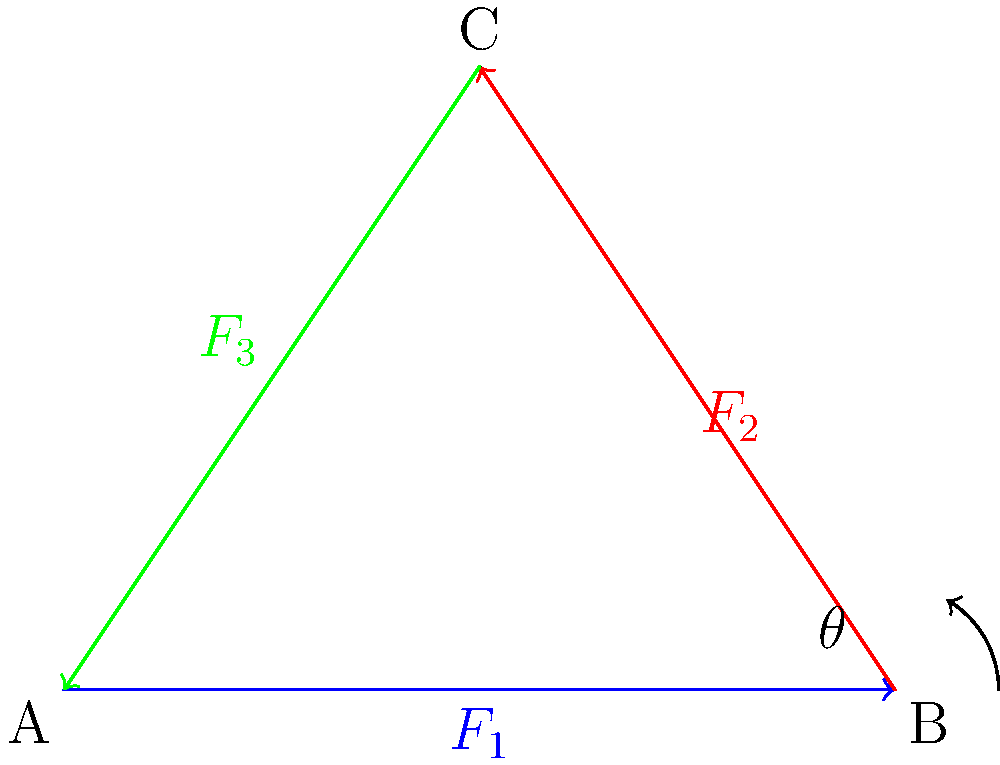In the robotic arm joint system schematic shown, three force vectors ($F_1$, $F_2$, and $F_3$) act on the triangular joint. If $F_1 = 100$ N, $F_2 = 80$ N, and the angle $\theta = 60°$, calculate the magnitude of $F_3$ required to maintain equilibrium in the system. To solve this problem, we'll use the principle of force equilibrium in a 2D plane. The steps are as follows:

1) For equilibrium, the sum of forces in both x and y directions must be zero:

   $$\sum F_x = 0$$ and $$\sum F_y = 0$$

2) Break down the forces into their x and y components:

   $F_1$: x-component = $F_1$, y-component = 0
   $F_2$: x-component = $F_2 \cos \theta$, y-component = $F_2 \sin \theta$
   $F_3$: x-component = $-F_3 \cos \alpha$, y-component = $-F_3 \sin \alpha$

   Where $\alpha$ is the angle $F_3$ makes with the negative x-axis.

3) Apply the equilibrium conditions:

   $$F_1 + F_2 \cos \theta - F_3 \cos \alpha = 0$$
   $$F_2 \sin \theta - F_3 \sin \alpha = 0$$

4) From the triangle geometry, we can deduce that $\alpha = 30°$ (complementary to $\theta$).

5) Substitute the known values:

   $$100 + 80 \cos 60° - F_3 \cos 30° = 0$$
   $$80 \sin 60° - F_3 \sin 30° = 0$$

6) Simplify:

   $$100 + 40 - 0.866F_3 = 0$$
   $$69.28 - 0.5F_3 = 0$$

7) From the second equation:

   $$F_3 = 138.56 \text{ N}$$

8) Verify this value in the first equation:

   $$100 + 40 - 0.866(138.56) \approx 0$$

Therefore, the magnitude of $F_3$ required to maintain equilibrium is approximately 138.56 N.
Answer: 138.56 N 